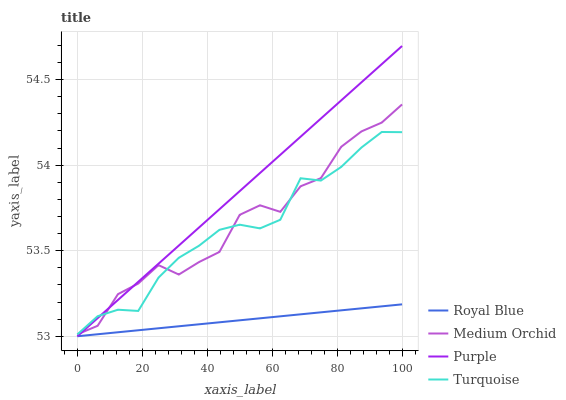Does Royal Blue have the minimum area under the curve?
Answer yes or no. Yes. Does Purple have the maximum area under the curve?
Answer yes or no. Yes. Does Turquoise have the minimum area under the curve?
Answer yes or no. No. Does Turquoise have the maximum area under the curve?
Answer yes or no. No. Is Royal Blue the smoothest?
Answer yes or no. Yes. Is Medium Orchid the roughest?
Answer yes or no. Yes. Is Turquoise the smoothest?
Answer yes or no. No. Is Turquoise the roughest?
Answer yes or no. No. Does Turquoise have the lowest value?
Answer yes or no. No. Does Purple have the highest value?
Answer yes or no. Yes. Does Turquoise have the highest value?
Answer yes or no. No. Is Royal Blue less than Medium Orchid?
Answer yes or no. Yes. Is Medium Orchid greater than Royal Blue?
Answer yes or no. Yes. Does Royal Blue intersect Medium Orchid?
Answer yes or no. No. 